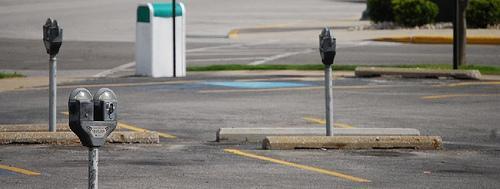How many trees are there?
Give a very brief answer. 1. How many parking meters are there?
Give a very brief answer. 3. 